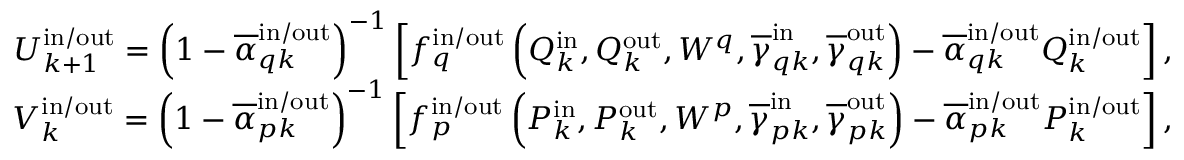<formula> <loc_0><loc_0><loc_500><loc_500>\begin{array} { r } { U _ { k + 1 } ^ { i n / o u t } = \left ( 1 - \overline { \alpha } _ { q k } ^ { i n / o u t } \right ) ^ { - 1 } \left [ f _ { q } ^ { i n / o u t } \left ( Q _ { k } ^ { i n } , Q _ { k } ^ { o u t } , W ^ { q } , \overline { \gamma } _ { q k } ^ { i n } , \overline { \gamma } _ { q k } ^ { o u t } \right ) - \overline { \alpha } _ { q k } ^ { i n / o u t } Q _ { k } ^ { i n / o u t } \right ] , } \\ { V _ { k } ^ { i n / o u t } = \left ( 1 - \overline { \alpha } _ { p k } ^ { i n / o u t } \right ) ^ { - 1 } \left [ f _ { p } ^ { i n / o u t } \left ( P _ { k } ^ { i n } , P _ { k } ^ { o u t } , W ^ { p } , \overline { \gamma } _ { p k } ^ { i n } , \overline { \gamma } _ { p k } ^ { o u t } \right ) - \overline { \alpha } _ { p k } ^ { i n / o u t } P _ { k } ^ { i n / o u t } \right ] , } \end{array}</formula> 